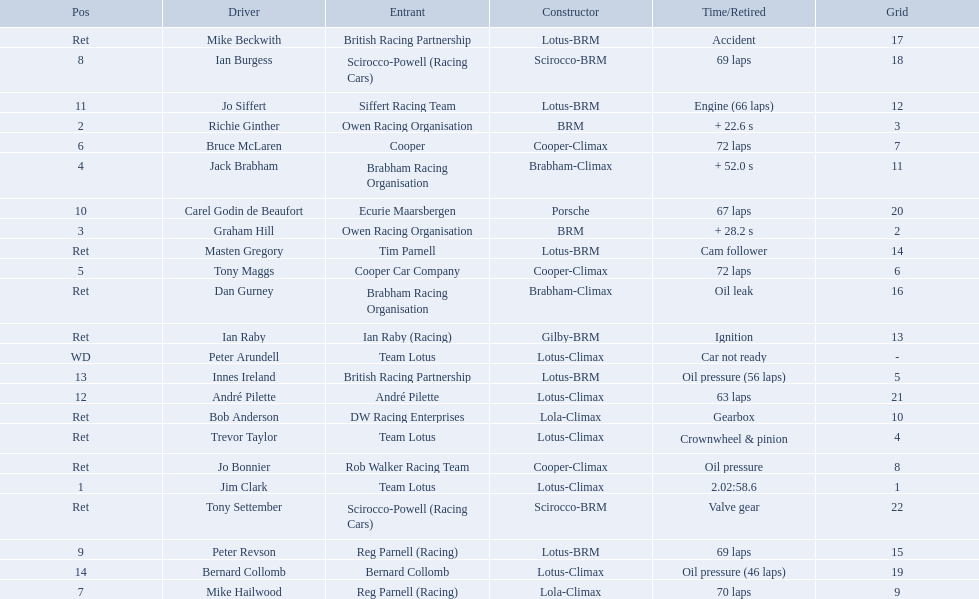Who are all the drivers? Jim Clark, Richie Ginther, Graham Hill, Jack Brabham, Tony Maggs, Bruce McLaren, Mike Hailwood, Ian Burgess, Peter Revson, Carel Godin de Beaufort, Jo Siffert, André Pilette, Innes Ireland, Bernard Collomb, Ian Raby, Dan Gurney, Mike Beckwith, Masten Gregory, Trevor Taylor, Jo Bonnier, Tony Settember, Bob Anderson, Peter Arundell. What were their positions? 1, 2, 3, 4, 5, 6, 7, 8, 9, 10, 11, 12, 13, 14, Ret, Ret, Ret, Ret, Ret, Ret, Ret, Ret, WD. What are all the constructor names? Lotus-Climax, BRM, BRM, Brabham-Climax, Cooper-Climax, Cooper-Climax, Lola-Climax, Scirocco-BRM, Lotus-BRM, Porsche, Lotus-BRM, Lotus-Climax, Lotus-BRM, Lotus-Climax, Gilby-BRM, Brabham-Climax, Lotus-BRM, Lotus-BRM, Lotus-Climax, Cooper-Climax, Scirocco-BRM, Lola-Climax, Lotus-Climax. And which drivers drove a cooper-climax? Tony Maggs, Bruce McLaren. Between those tow, who was positioned higher? Tony Maggs. Who drove in the 1963 international gold cup? Jim Clark, Richie Ginther, Graham Hill, Jack Brabham, Tony Maggs, Bruce McLaren, Mike Hailwood, Ian Burgess, Peter Revson, Carel Godin de Beaufort, Jo Siffert, André Pilette, Innes Ireland, Bernard Collomb, Ian Raby, Dan Gurney, Mike Beckwith, Masten Gregory, Trevor Taylor, Jo Bonnier, Tony Settember, Bob Anderson, Peter Arundell. Who had problems during the race? Jo Siffert, Innes Ireland, Bernard Collomb, Ian Raby, Dan Gurney, Mike Beckwith, Masten Gregory, Trevor Taylor, Jo Bonnier, Tony Settember, Bob Anderson, Peter Arundell. Of those who was still able to finish the race? Jo Siffert, Innes Ireland, Bernard Collomb. Of those who faced the same issue? Innes Ireland, Bernard Collomb. What issue did they have? Oil pressure. 